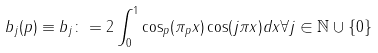<formula> <loc_0><loc_0><loc_500><loc_500>b _ { j } ( p ) \equiv b _ { j } \colon = 2 \int _ { 0 } ^ { 1 } \cos _ { p } ( \pi _ { p } x ) \cos ( j \pi x ) d x \forall j \in \mathbb { N } \cup \{ 0 \}</formula> 